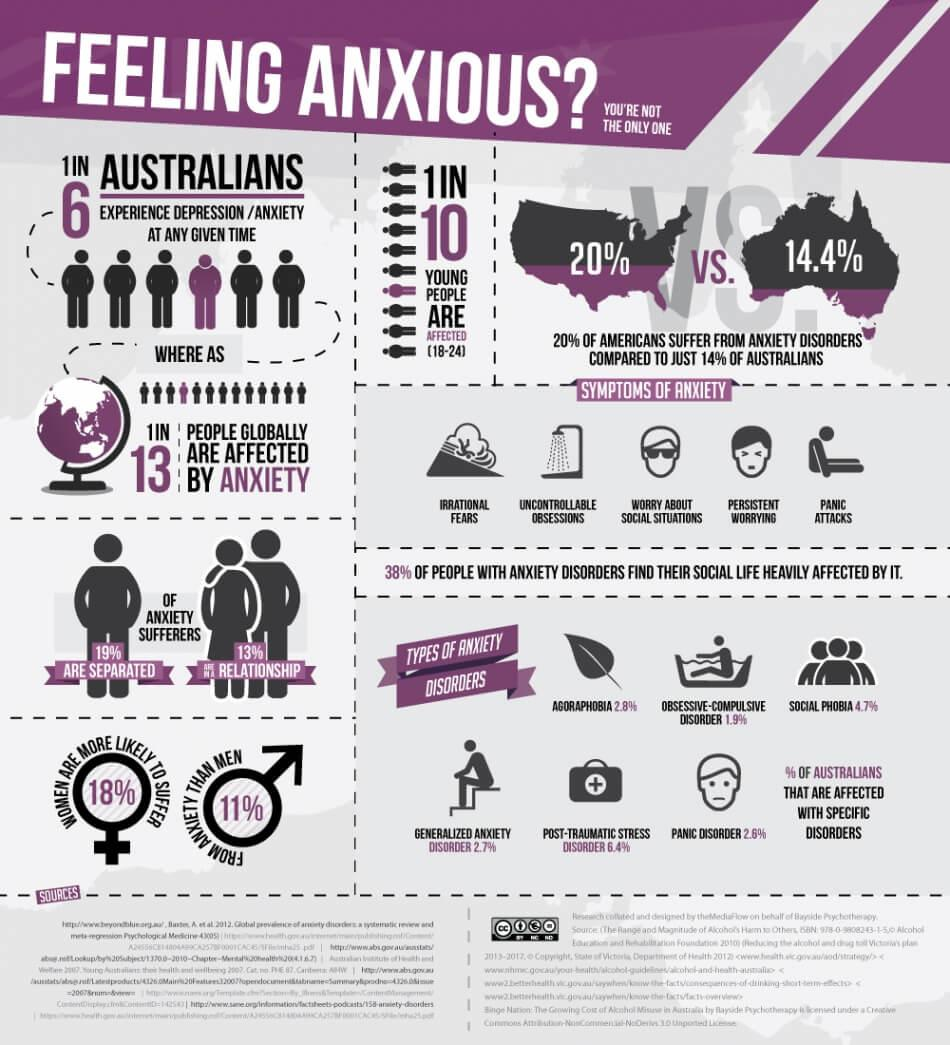Point out several critical features in this image. It is estimated that approximately 80% of Americans do not suffer from anxiety disorders. According to statistics, approximately 13% of individuals in Australia who suffer from anxiety are currently in a relationship. In Australia, Obsessive-Compulsive Disorder appears to have the least impact among anxiety disorders. According to statistics, 11% of men in Australia are more likely to suffer from anxiety. In Australia, it is estimated that 18% of women are more likely to suffer from anxiety. 